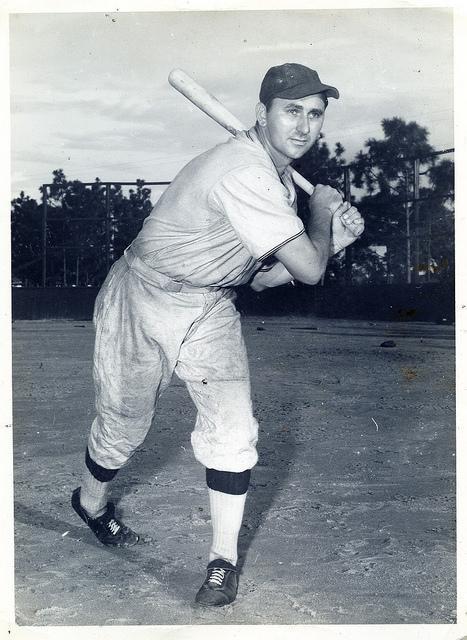How many bottles is the lady touching?
Give a very brief answer. 0. 